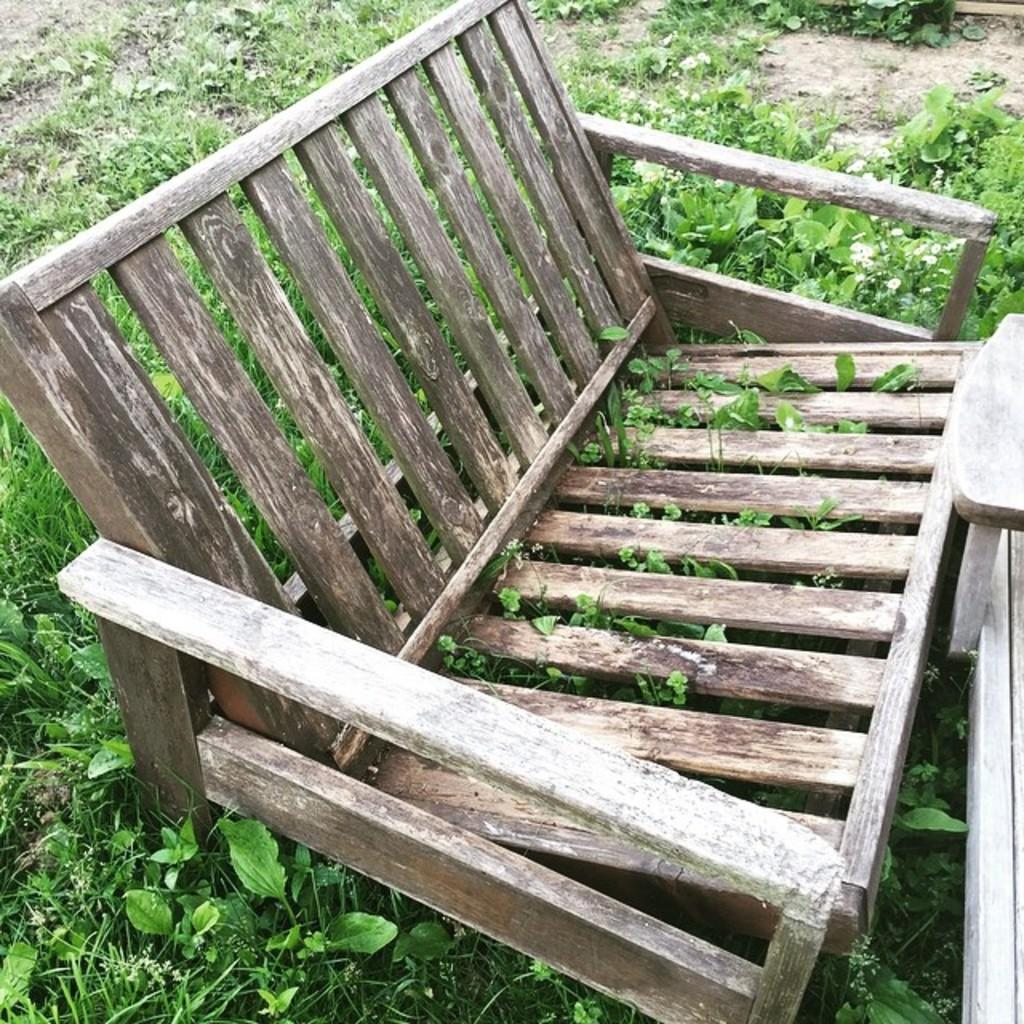What type of seating is visible in the picture? There is a wooden bench in the picture. What type of ground surface is present in the picture? There is grass in the picture. What type of vegetation is present in the picture? There are plants in the picture. Can you describe the wooden object on the right side of the picture? There is a wooden object at the right side of the picture, but its specific purpose or function is not clear from the provided facts. How does the wooden bench say good-bye to the plants in the picture? The wooden bench does not have the ability to say good-bye or communicate in any way, as it is an inanimate object. What type of error is present in the picture? There is no mention of any errors or mistakes in the picture, so it is not possible to answer this question. 